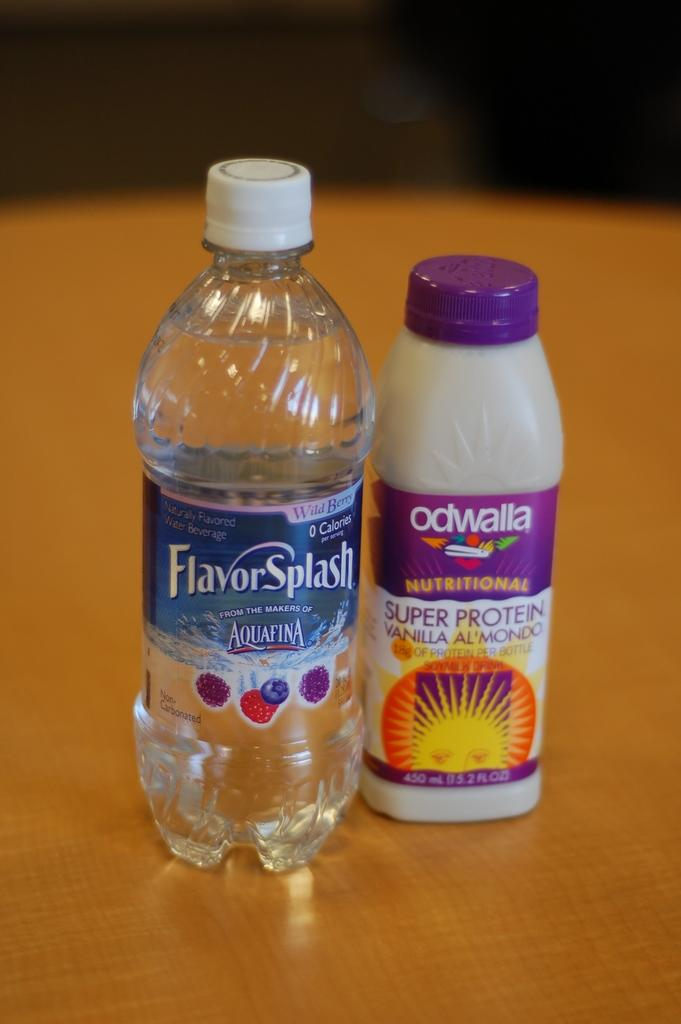<image>
Describe the image concisely. A bottle of water claims to have a Flavor Splash. 